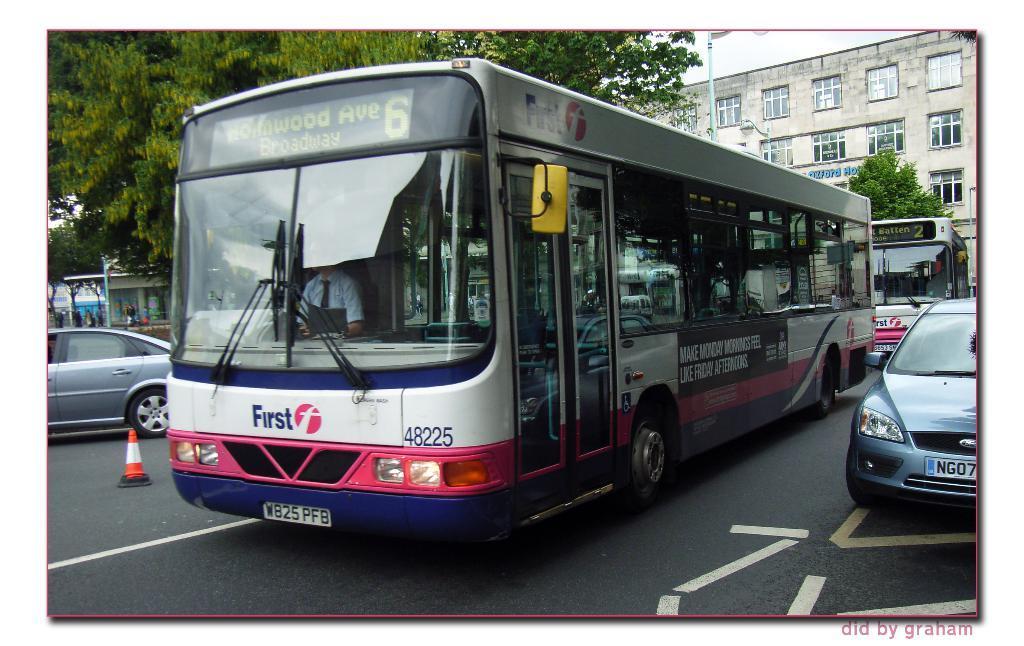Describe this image in one or two sentences. In this picture we can see white and pink color bus on the road. Beside we can see silver color car is parked on the road side. Behind we can see another bus and a white color building with many windows. In front bottom side we can see a traffic cones on the road. 